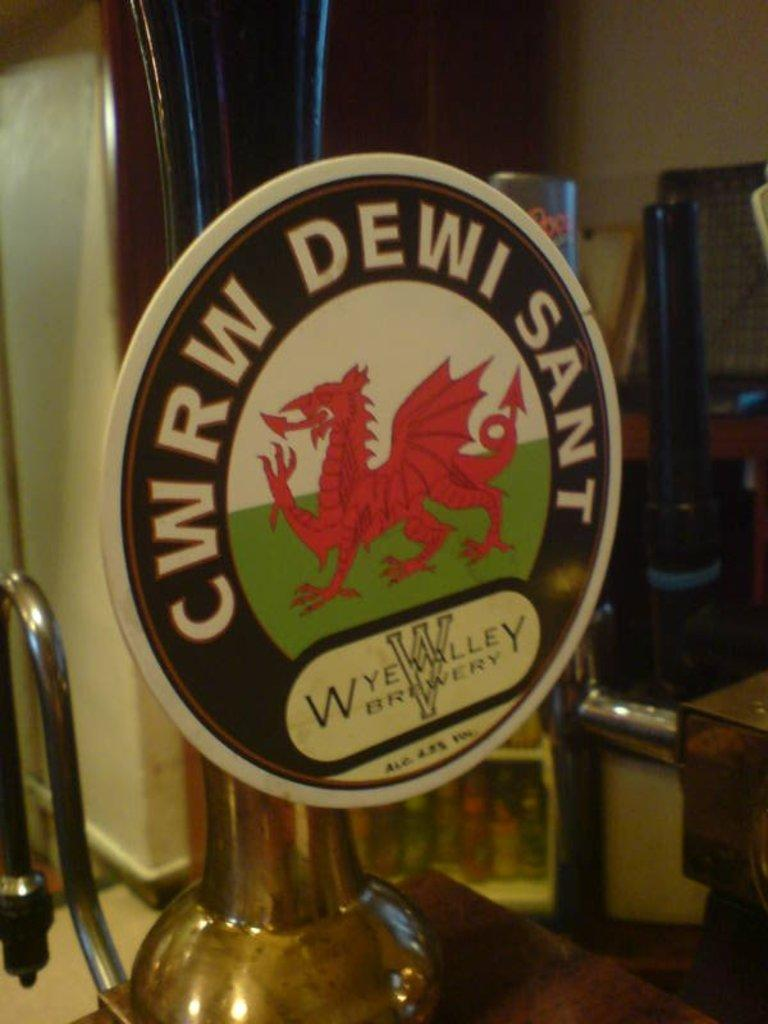<image>
Give a short and clear explanation of the subsequent image. A round sign that says CWRW DEWI SANT on it is attached to something silver. 